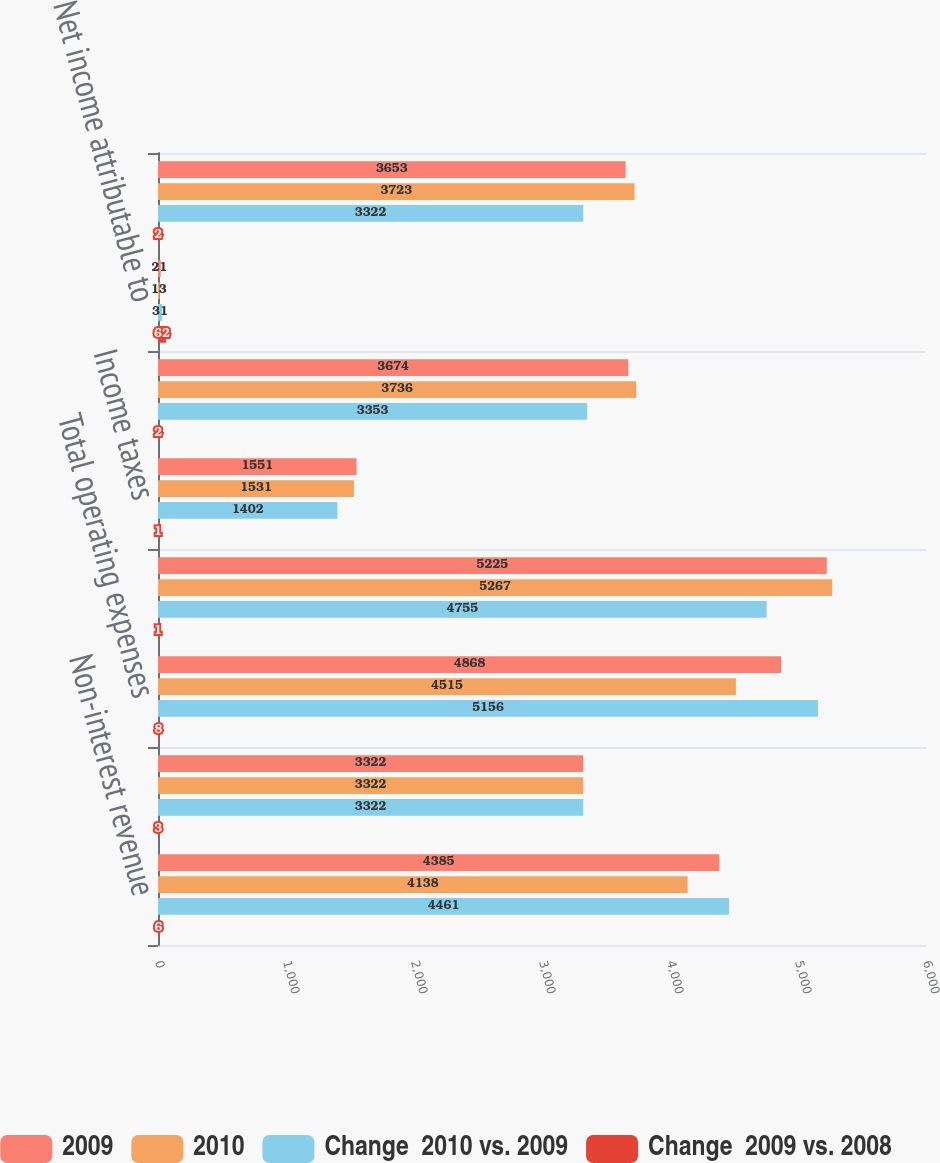Convert chart. <chart><loc_0><loc_0><loc_500><loc_500><stacked_bar_chart><ecel><fcel>Non-interest revenue<fcel>Total revenues net of interest<fcel>Total operating expenses<fcel>Income before taxes and<fcel>Income taxes<fcel>Income from continuing<fcel>Net income attributable to<fcel>Net income<nl><fcel>2009<fcel>4385<fcel>3322<fcel>4868<fcel>5225<fcel>1551<fcel>3674<fcel>21<fcel>3653<nl><fcel>2010<fcel>4138<fcel>3322<fcel>4515<fcel>5267<fcel>1531<fcel>3736<fcel>13<fcel>3723<nl><fcel>Change  2010 vs. 2009<fcel>4461<fcel>3322<fcel>5156<fcel>4755<fcel>1402<fcel>3353<fcel>31<fcel>3322<nl><fcel>Change  2009 vs. 2008<fcel>6<fcel>3<fcel>8<fcel>1<fcel>1<fcel>2<fcel>62<fcel>2<nl></chart> 